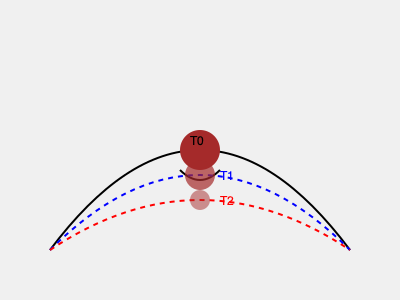Based on the 3D model representation of an archaeological site over time, predict the most likely state of the artifact at time T2, considering the effects of erosion. What factor would most significantly influence the rate of erosion in this scenario? To answer this question, we need to analyze the given 3D model representation and understand the process of erosion on archaeological remains:

1. Initial state (T0):
   - The artifact is represented by a brown circle at the top of a hill-like formation.
   - The land surface is shown as a curved black line.

2. First erosion stage (T1):
   - The blue dashed line represents the eroded land surface.
   - The artifact has moved downslope and decreased in size.

3. Second erosion stage (T2):
   - The red dashed line shows further erosion of the land surface.
   - The artifact has moved further downslope and decreased more in size.

4. Erosion process analysis:
   - The model shows a consistent pattern of downslope movement and size reduction of the artifact.
   - The land surface is gradually flattening, indicating ongoing erosion.

5. Prediction for T2:
   - Based on the observed pattern, at T2, the artifact would be smaller and located lower on the slope.
   - It would be partially buried or more exposed, depending on the erosion rate and deposition.

6. Factors influencing erosion rate:
   - Slope gradient: Steeper slopes generally lead to faster erosion.
   - Rainfall intensity and frequency: More rainfall typically increases erosion.
   - Soil type and composition: Some soils are more susceptible to erosion than others.
   - Vegetation cover: Lack of vegetation can accelerate erosion.
   - Human activities: Such as construction or land-use changes can significantly impact erosion rates.

Considering the archaeological context, the most significant factor influencing erosion rate would likely be rainfall intensity and frequency. This is because:
   - It directly affects the rate of surface runoff and soil movement.
   - It can cause both physical erosion and chemical weathering of artifacts.
   - It's a dynamic factor that can change relatively quickly compared to other factors like slope or soil type.
   - In archaeological sites, rainfall can have a profound impact on artifact preservation and site integrity.
Answer: Rainfall intensity and frequency 